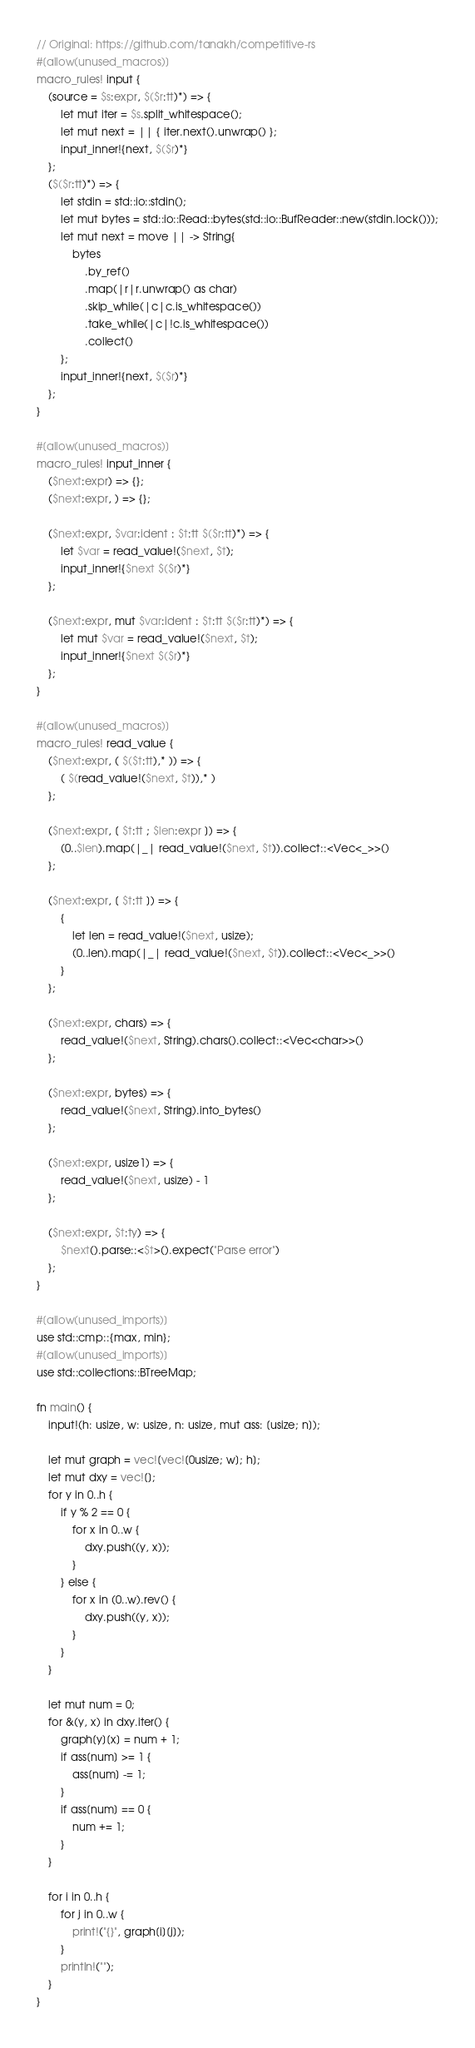<code> <loc_0><loc_0><loc_500><loc_500><_Rust_>// Original: https://github.com/tanakh/competitive-rs
#[allow(unused_macros)]
macro_rules! input {
    (source = $s:expr, $($r:tt)*) => {
        let mut iter = $s.split_whitespace();
        let mut next = || { iter.next().unwrap() };
        input_inner!{next, $($r)*}
    };
    ($($r:tt)*) => {
        let stdin = std::io::stdin();
        let mut bytes = std::io::Read::bytes(std::io::BufReader::new(stdin.lock()));
        let mut next = move || -> String{
            bytes
                .by_ref()
                .map(|r|r.unwrap() as char)
                .skip_while(|c|c.is_whitespace())
                .take_while(|c|!c.is_whitespace())
                .collect()
        };
        input_inner!{next, $($r)*}
    };
}

#[allow(unused_macros)]
macro_rules! input_inner {
    ($next:expr) => {};
    ($next:expr, ) => {};

    ($next:expr, $var:ident : $t:tt $($r:tt)*) => {
        let $var = read_value!($next, $t);
        input_inner!{$next $($r)*}
    };

    ($next:expr, mut $var:ident : $t:tt $($r:tt)*) => {
        let mut $var = read_value!($next, $t);
        input_inner!{$next $($r)*}
    };
}

#[allow(unused_macros)]
macro_rules! read_value {
    ($next:expr, ( $($t:tt),* )) => {
        ( $(read_value!($next, $t)),* )
    };

    ($next:expr, [ $t:tt ; $len:expr ]) => {
        (0..$len).map(|_| read_value!($next, $t)).collect::<Vec<_>>()
    };

    ($next:expr, [ $t:tt ]) => {
        {
            let len = read_value!($next, usize);
            (0..len).map(|_| read_value!($next, $t)).collect::<Vec<_>>()
        }
    };

    ($next:expr, chars) => {
        read_value!($next, String).chars().collect::<Vec<char>>()
    };

    ($next:expr, bytes) => {
        read_value!($next, String).into_bytes()
    };

    ($next:expr, usize1) => {
        read_value!($next, usize) - 1
    };

    ($next:expr, $t:ty) => {
        $next().parse::<$t>().expect("Parse error")
    };
}

#[allow(unused_imports)]
use std::cmp::{max, min};
#[allow(unused_imports)]
use std::collections::BTreeMap;

fn main() {
    input!(h: usize, w: usize, n: usize, mut ass: [usize; n]);

    let mut graph = vec![vec![0usize; w]; h];
    let mut dxy = vec![];
    for y in 0..h {
        if y % 2 == 0 {
            for x in 0..w {
                dxy.push((y, x));
            }
        } else {
            for x in (0..w).rev() {
                dxy.push((y, x));
            }
        }
    }

    let mut num = 0;
    for &(y, x) in dxy.iter() {
        graph[y][x] = num + 1;
        if ass[num] >= 1 {
            ass[num] -= 1;
        }
        if ass[num] == 0 {
            num += 1;
        }
    }

    for i in 0..h {
        for j in 0..w {
            print!("{}", graph[i][j]);
        }
        println!("");
    }
}
</code> 